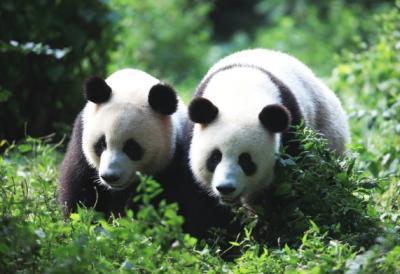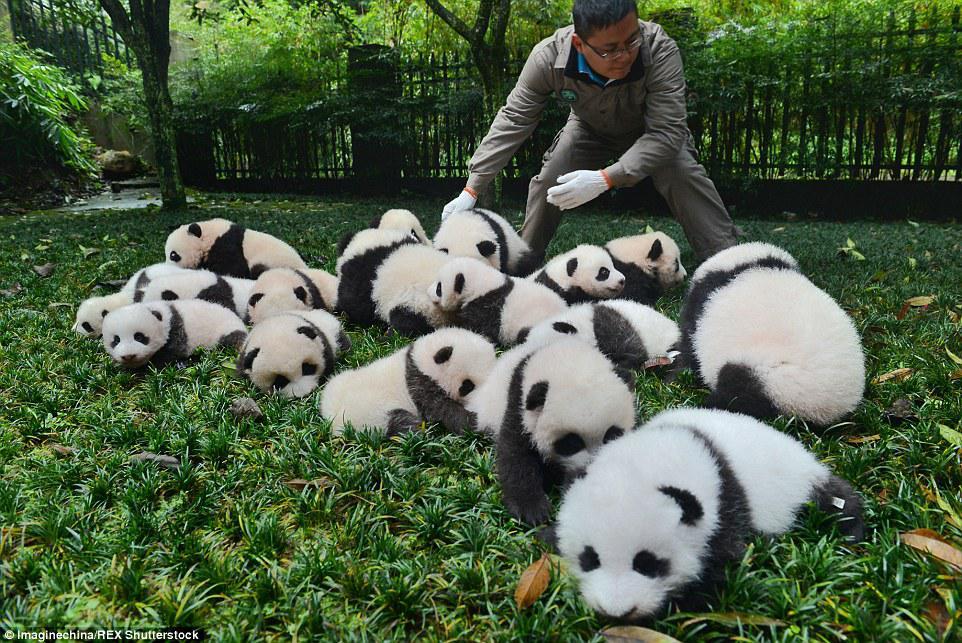The first image is the image on the left, the second image is the image on the right. Evaluate the accuracy of this statement regarding the images: "there is at least one panda in a tree in the image pair". Is it true? Answer yes or no. No. The first image is the image on the left, the second image is the image on the right. Analyze the images presented: Is the assertion "At least one panda is in a tree." valid? Answer yes or no. No. 